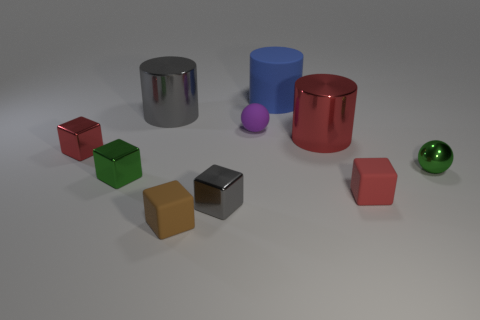Subtract 1 cubes. How many cubes are left? 4 Subtract all cyan cubes. Subtract all blue spheres. How many cubes are left? 5 Subtract all cylinders. How many objects are left? 7 Subtract 1 blue cylinders. How many objects are left? 9 Subtract all tiny brown metallic cylinders. Subtract all gray things. How many objects are left? 8 Add 8 gray cubes. How many gray cubes are left? 9 Add 8 green metallic balls. How many green metallic balls exist? 9 